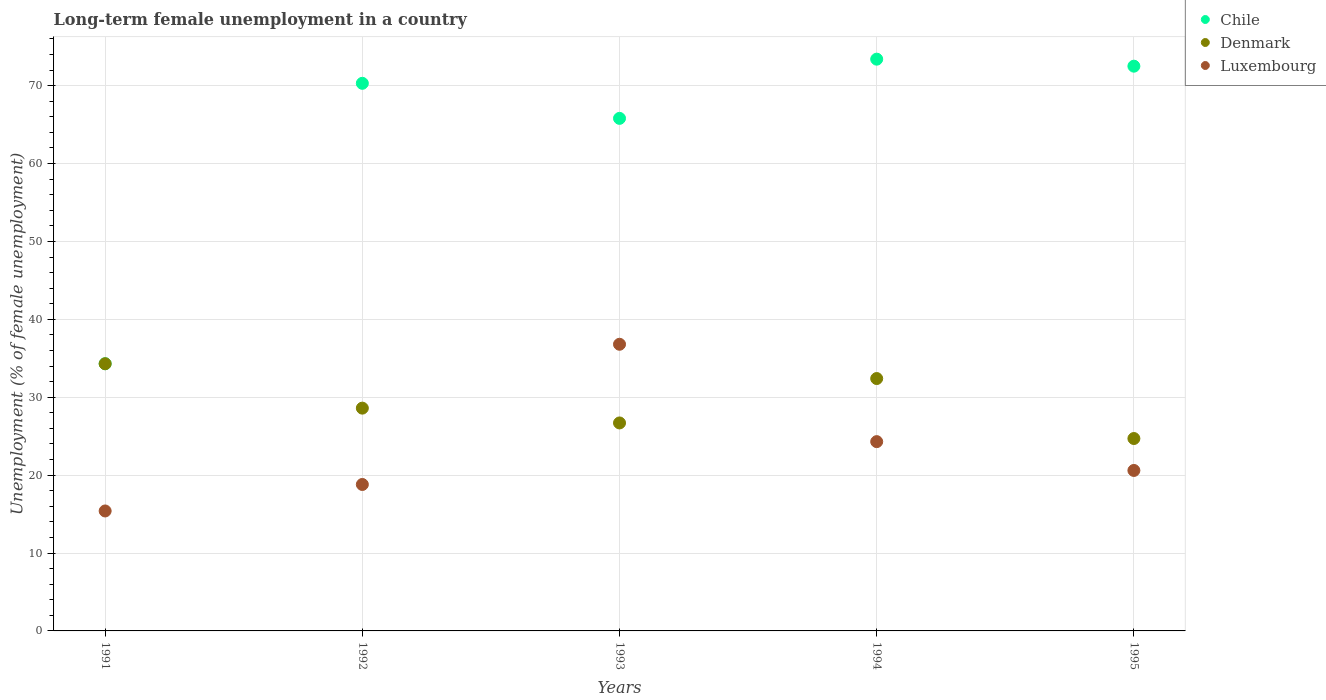How many different coloured dotlines are there?
Your response must be concise. 3. Is the number of dotlines equal to the number of legend labels?
Give a very brief answer. Yes. What is the percentage of long-term unemployed female population in Luxembourg in 1993?
Provide a succinct answer. 36.8. Across all years, what is the maximum percentage of long-term unemployed female population in Luxembourg?
Give a very brief answer. 36.8. Across all years, what is the minimum percentage of long-term unemployed female population in Luxembourg?
Offer a very short reply. 15.4. In which year was the percentage of long-term unemployed female population in Luxembourg maximum?
Make the answer very short. 1993. In which year was the percentage of long-term unemployed female population in Denmark minimum?
Offer a terse response. 1995. What is the total percentage of long-term unemployed female population in Denmark in the graph?
Provide a short and direct response. 146.7. What is the difference between the percentage of long-term unemployed female population in Denmark in 1992 and that in 1994?
Ensure brevity in your answer.  -3.8. What is the difference between the percentage of long-term unemployed female population in Denmark in 1991 and the percentage of long-term unemployed female population in Luxembourg in 1995?
Offer a very short reply. 13.7. What is the average percentage of long-term unemployed female population in Luxembourg per year?
Make the answer very short. 23.18. In the year 1992, what is the difference between the percentage of long-term unemployed female population in Denmark and percentage of long-term unemployed female population in Chile?
Offer a terse response. -41.7. In how many years, is the percentage of long-term unemployed female population in Luxembourg greater than 58 %?
Offer a very short reply. 0. What is the ratio of the percentage of long-term unemployed female population in Denmark in 1991 to that in 1995?
Provide a succinct answer. 1.39. What is the difference between the highest and the second highest percentage of long-term unemployed female population in Luxembourg?
Offer a very short reply. 12.5. What is the difference between the highest and the lowest percentage of long-term unemployed female population in Chile?
Your answer should be very brief. 39.1. Is the sum of the percentage of long-term unemployed female population in Denmark in 1993 and 1995 greater than the maximum percentage of long-term unemployed female population in Luxembourg across all years?
Provide a short and direct response. Yes. Does the percentage of long-term unemployed female population in Denmark monotonically increase over the years?
Provide a succinct answer. No. Is the percentage of long-term unemployed female population in Denmark strictly less than the percentage of long-term unemployed female population in Chile over the years?
Make the answer very short. No. What is the difference between two consecutive major ticks on the Y-axis?
Make the answer very short. 10. Are the values on the major ticks of Y-axis written in scientific E-notation?
Provide a short and direct response. No. Does the graph contain any zero values?
Provide a short and direct response. No. Does the graph contain grids?
Make the answer very short. Yes. Where does the legend appear in the graph?
Give a very brief answer. Top right. How are the legend labels stacked?
Offer a very short reply. Vertical. What is the title of the graph?
Ensure brevity in your answer.  Long-term female unemployment in a country. Does "Nigeria" appear as one of the legend labels in the graph?
Keep it short and to the point. No. What is the label or title of the Y-axis?
Make the answer very short. Unemployment (% of female unemployment). What is the Unemployment (% of female unemployment) in Chile in 1991?
Your answer should be very brief. 34.3. What is the Unemployment (% of female unemployment) of Denmark in 1991?
Your answer should be compact. 34.3. What is the Unemployment (% of female unemployment) of Luxembourg in 1991?
Your answer should be very brief. 15.4. What is the Unemployment (% of female unemployment) of Chile in 1992?
Your answer should be compact. 70.3. What is the Unemployment (% of female unemployment) in Denmark in 1992?
Your answer should be compact. 28.6. What is the Unemployment (% of female unemployment) of Luxembourg in 1992?
Give a very brief answer. 18.8. What is the Unemployment (% of female unemployment) of Chile in 1993?
Provide a short and direct response. 65.8. What is the Unemployment (% of female unemployment) in Denmark in 1993?
Provide a succinct answer. 26.7. What is the Unemployment (% of female unemployment) of Luxembourg in 1993?
Give a very brief answer. 36.8. What is the Unemployment (% of female unemployment) in Chile in 1994?
Your answer should be very brief. 73.4. What is the Unemployment (% of female unemployment) in Denmark in 1994?
Offer a terse response. 32.4. What is the Unemployment (% of female unemployment) of Luxembourg in 1994?
Your response must be concise. 24.3. What is the Unemployment (% of female unemployment) of Chile in 1995?
Offer a terse response. 72.5. What is the Unemployment (% of female unemployment) of Denmark in 1995?
Provide a short and direct response. 24.7. What is the Unemployment (% of female unemployment) in Luxembourg in 1995?
Ensure brevity in your answer.  20.6. Across all years, what is the maximum Unemployment (% of female unemployment) in Chile?
Your answer should be compact. 73.4. Across all years, what is the maximum Unemployment (% of female unemployment) in Denmark?
Ensure brevity in your answer.  34.3. Across all years, what is the maximum Unemployment (% of female unemployment) of Luxembourg?
Ensure brevity in your answer.  36.8. Across all years, what is the minimum Unemployment (% of female unemployment) of Chile?
Provide a short and direct response. 34.3. Across all years, what is the minimum Unemployment (% of female unemployment) of Denmark?
Your response must be concise. 24.7. Across all years, what is the minimum Unemployment (% of female unemployment) in Luxembourg?
Your answer should be compact. 15.4. What is the total Unemployment (% of female unemployment) of Chile in the graph?
Offer a very short reply. 316.3. What is the total Unemployment (% of female unemployment) in Denmark in the graph?
Provide a short and direct response. 146.7. What is the total Unemployment (% of female unemployment) of Luxembourg in the graph?
Offer a very short reply. 115.9. What is the difference between the Unemployment (% of female unemployment) in Chile in 1991 and that in 1992?
Ensure brevity in your answer.  -36. What is the difference between the Unemployment (% of female unemployment) of Denmark in 1991 and that in 1992?
Your answer should be very brief. 5.7. What is the difference between the Unemployment (% of female unemployment) of Chile in 1991 and that in 1993?
Ensure brevity in your answer.  -31.5. What is the difference between the Unemployment (% of female unemployment) in Denmark in 1991 and that in 1993?
Offer a very short reply. 7.6. What is the difference between the Unemployment (% of female unemployment) of Luxembourg in 1991 and that in 1993?
Provide a succinct answer. -21.4. What is the difference between the Unemployment (% of female unemployment) of Chile in 1991 and that in 1994?
Your answer should be very brief. -39.1. What is the difference between the Unemployment (% of female unemployment) in Chile in 1991 and that in 1995?
Make the answer very short. -38.2. What is the difference between the Unemployment (% of female unemployment) of Luxembourg in 1991 and that in 1995?
Ensure brevity in your answer.  -5.2. What is the difference between the Unemployment (% of female unemployment) of Chile in 1992 and that in 1993?
Provide a short and direct response. 4.5. What is the difference between the Unemployment (% of female unemployment) of Denmark in 1992 and that in 1993?
Provide a succinct answer. 1.9. What is the difference between the Unemployment (% of female unemployment) in Luxembourg in 1992 and that in 1993?
Your response must be concise. -18. What is the difference between the Unemployment (% of female unemployment) in Chile in 1993 and that in 1995?
Your response must be concise. -6.7. What is the difference between the Unemployment (% of female unemployment) in Denmark in 1993 and that in 1995?
Give a very brief answer. 2. What is the difference between the Unemployment (% of female unemployment) in Luxembourg in 1993 and that in 1995?
Provide a short and direct response. 16.2. What is the difference between the Unemployment (% of female unemployment) in Denmark in 1994 and that in 1995?
Keep it short and to the point. 7.7. What is the difference between the Unemployment (% of female unemployment) in Luxembourg in 1994 and that in 1995?
Your response must be concise. 3.7. What is the difference between the Unemployment (% of female unemployment) in Chile in 1991 and the Unemployment (% of female unemployment) in Luxembourg in 1992?
Ensure brevity in your answer.  15.5. What is the difference between the Unemployment (% of female unemployment) of Chile in 1991 and the Unemployment (% of female unemployment) of Luxembourg in 1993?
Your answer should be compact. -2.5. What is the difference between the Unemployment (% of female unemployment) in Chile in 1991 and the Unemployment (% of female unemployment) in Denmark in 1994?
Your answer should be very brief. 1.9. What is the difference between the Unemployment (% of female unemployment) in Denmark in 1991 and the Unemployment (% of female unemployment) in Luxembourg in 1994?
Offer a terse response. 10. What is the difference between the Unemployment (% of female unemployment) of Chile in 1992 and the Unemployment (% of female unemployment) of Denmark in 1993?
Make the answer very short. 43.6. What is the difference between the Unemployment (% of female unemployment) of Chile in 1992 and the Unemployment (% of female unemployment) of Luxembourg in 1993?
Offer a terse response. 33.5. What is the difference between the Unemployment (% of female unemployment) of Chile in 1992 and the Unemployment (% of female unemployment) of Denmark in 1994?
Give a very brief answer. 37.9. What is the difference between the Unemployment (% of female unemployment) of Chile in 1992 and the Unemployment (% of female unemployment) of Luxembourg in 1994?
Provide a succinct answer. 46. What is the difference between the Unemployment (% of female unemployment) in Denmark in 1992 and the Unemployment (% of female unemployment) in Luxembourg in 1994?
Offer a terse response. 4.3. What is the difference between the Unemployment (% of female unemployment) in Chile in 1992 and the Unemployment (% of female unemployment) in Denmark in 1995?
Give a very brief answer. 45.6. What is the difference between the Unemployment (% of female unemployment) in Chile in 1992 and the Unemployment (% of female unemployment) in Luxembourg in 1995?
Your answer should be compact. 49.7. What is the difference between the Unemployment (% of female unemployment) in Denmark in 1992 and the Unemployment (% of female unemployment) in Luxembourg in 1995?
Your answer should be compact. 8. What is the difference between the Unemployment (% of female unemployment) of Chile in 1993 and the Unemployment (% of female unemployment) of Denmark in 1994?
Your answer should be compact. 33.4. What is the difference between the Unemployment (% of female unemployment) in Chile in 1993 and the Unemployment (% of female unemployment) in Luxembourg in 1994?
Ensure brevity in your answer.  41.5. What is the difference between the Unemployment (% of female unemployment) of Chile in 1993 and the Unemployment (% of female unemployment) of Denmark in 1995?
Ensure brevity in your answer.  41.1. What is the difference between the Unemployment (% of female unemployment) in Chile in 1993 and the Unemployment (% of female unemployment) in Luxembourg in 1995?
Make the answer very short. 45.2. What is the difference between the Unemployment (% of female unemployment) of Denmark in 1993 and the Unemployment (% of female unemployment) of Luxembourg in 1995?
Give a very brief answer. 6.1. What is the difference between the Unemployment (% of female unemployment) of Chile in 1994 and the Unemployment (% of female unemployment) of Denmark in 1995?
Offer a terse response. 48.7. What is the difference between the Unemployment (% of female unemployment) of Chile in 1994 and the Unemployment (% of female unemployment) of Luxembourg in 1995?
Give a very brief answer. 52.8. What is the average Unemployment (% of female unemployment) of Chile per year?
Your answer should be very brief. 63.26. What is the average Unemployment (% of female unemployment) in Denmark per year?
Provide a succinct answer. 29.34. What is the average Unemployment (% of female unemployment) in Luxembourg per year?
Your answer should be compact. 23.18. In the year 1991, what is the difference between the Unemployment (% of female unemployment) in Chile and Unemployment (% of female unemployment) in Denmark?
Provide a short and direct response. 0. In the year 1992, what is the difference between the Unemployment (% of female unemployment) of Chile and Unemployment (% of female unemployment) of Denmark?
Keep it short and to the point. 41.7. In the year 1992, what is the difference between the Unemployment (% of female unemployment) in Chile and Unemployment (% of female unemployment) in Luxembourg?
Give a very brief answer. 51.5. In the year 1993, what is the difference between the Unemployment (% of female unemployment) of Chile and Unemployment (% of female unemployment) of Denmark?
Ensure brevity in your answer.  39.1. In the year 1993, what is the difference between the Unemployment (% of female unemployment) of Chile and Unemployment (% of female unemployment) of Luxembourg?
Your answer should be compact. 29. In the year 1994, what is the difference between the Unemployment (% of female unemployment) in Chile and Unemployment (% of female unemployment) in Luxembourg?
Provide a succinct answer. 49.1. In the year 1994, what is the difference between the Unemployment (% of female unemployment) in Denmark and Unemployment (% of female unemployment) in Luxembourg?
Your response must be concise. 8.1. In the year 1995, what is the difference between the Unemployment (% of female unemployment) in Chile and Unemployment (% of female unemployment) in Denmark?
Provide a short and direct response. 47.8. In the year 1995, what is the difference between the Unemployment (% of female unemployment) of Chile and Unemployment (% of female unemployment) of Luxembourg?
Provide a succinct answer. 51.9. In the year 1995, what is the difference between the Unemployment (% of female unemployment) in Denmark and Unemployment (% of female unemployment) in Luxembourg?
Offer a very short reply. 4.1. What is the ratio of the Unemployment (% of female unemployment) in Chile in 1991 to that in 1992?
Make the answer very short. 0.49. What is the ratio of the Unemployment (% of female unemployment) of Denmark in 1991 to that in 1992?
Offer a terse response. 1.2. What is the ratio of the Unemployment (% of female unemployment) of Luxembourg in 1991 to that in 1992?
Keep it short and to the point. 0.82. What is the ratio of the Unemployment (% of female unemployment) in Chile in 1991 to that in 1993?
Give a very brief answer. 0.52. What is the ratio of the Unemployment (% of female unemployment) in Denmark in 1991 to that in 1993?
Keep it short and to the point. 1.28. What is the ratio of the Unemployment (% of female unemployment) in Luxembourg in 1991 to that in 1993?
Ensure brevity in your answer.  0.42. What is the ratio of the Unemployment (% of female unemployment) in Chile in 1991 to that in 1994?
Ensure brevity in your answer.  0.47. What is the ratio of the Unemployment (% of female unemployment) of Denmark in 1991 to that in 1994?
Provide a succinct answer. 1.06. What is the ratio of the Unemployment (% of female unemployment) in Luxembourg in 1991 to that in 1994?
Your answer should be compact. 0.63. What is the ratio of the Unemployment (% of female unemployment) in Chile in 1991 to that in 1995?
Make the answer very short. 0.47. What is the ratio of the Unemployment (% of female unemployment) of Denmark in 1991 to that in 1995?
Offer a terse response. 1.39. What is the ratio of the Unemployment (% of female unemployment) in Luxembourg in 1991 to that in 1995?
Your answer should be very brief. 0.75. What is the ratio of the Unemployment (% of female unemployment) of Chile in 1992 to that in 1993?
Your answer should be very brief. 1.07. What is the ratio of the Unemployment (% of female unemployment) in Denmark in 1992 to that in 1993?
Offer a very short reply. 1.07. What is the ratio of the Unemployment (% of female unemployment) in Luxembourg in 1992 to that in 1993?
Give a very brief answer. 0.51. What is the ratio of the Unemployment (% of female unemployment) in Chile in 1992 to that in 1994?
Ensure brevity in your answer.  0.96. What is the ratio of the Unemployment (% of female unemployment) in Denmark in 1992 to that in 1994?
Your response must be concise. 0.88. What is the ratio of the Unemployment (% of female unemployment) of Luxembourg in 1992 to that in 1994?
Give a very brief answer. 0.77. What is the ratio of the Unemployment (% of female unemployment) in Chile in 1992 to that in 1995?
Your answer should be very brief. 0.97. What is the ratio of the Unemployment (% of female unemployment) in Denmark in 1992 to that in 1995?
Provide a succinct answer. 1.16. What is the ratio of the Unemployment (% of female unemployment) of Luxembourg in 1992 to that in 1995?
Offer a terse response. 0.91. What is the ratio of the Unemployment (% of female unemployment) of Chile in 1993 to that in 1994?
Make the answer very short. 0.9. What is the ratio of the Unemployment (% of female unemployment) of Denmark in 1993 to that in 1994?
Offer a very short reply. 0.82. What is the ratio of the Unemployment (% of female unemployment) in Luxembourg in 1993 to that in 1994?
Provide a succinct answer. 1.51. What is the ratio of the Unemployment (% of female unemployment) in Chile in 1993 to that in 1995?
Offer a very short reply. 0.91. What is the ratio of the Unemployment (% of female unemployment) in Denmark in 1993 to that in 1995?
Give a very brief answer. 1.08. What is the ratio of the Unemployment (% of female unemployment) in Luxembourg in 1993 to that in 1995?
Your answer should be very brief. 1.79. What is the ratio of the Unemployment (% of female unemployment) of Chile in 1994 to that in 1995?
Keep it short and to the point. 1.01. What is the ratio of the Unemployment (% of female unemployment) in Denmark in 1994 to that in 1995?
Offer a very short reply. 1.31. What is the ratio of the Unemployment (% of female unemployment) in Luxembourg in 1994 to that in 1995?
Provide a short and direct response. 1.18. What is the difference between the highest and the second highest Unemployment (% of female unemployment) of Chile?
Keep it short and to the point. 0.9. What is the difference between the highest and the second highest Unemployment (% of female unemployment) of Denmark?
Offer a terse response. 1.9. What is the difference between the highest and the lowest Unemployment (% of female unemployment) in Chile?
Make the answer very short. 39.1. What is the difference between the highest and the lowest Unemployment (% of female unemployment) in Denmark?
Provide a succinct answer. 9.6. What is the difference between the highest and the lowest Unemployment (% of female unemployment) of Luxembourg?
Your answer should be compact. 21.4. 